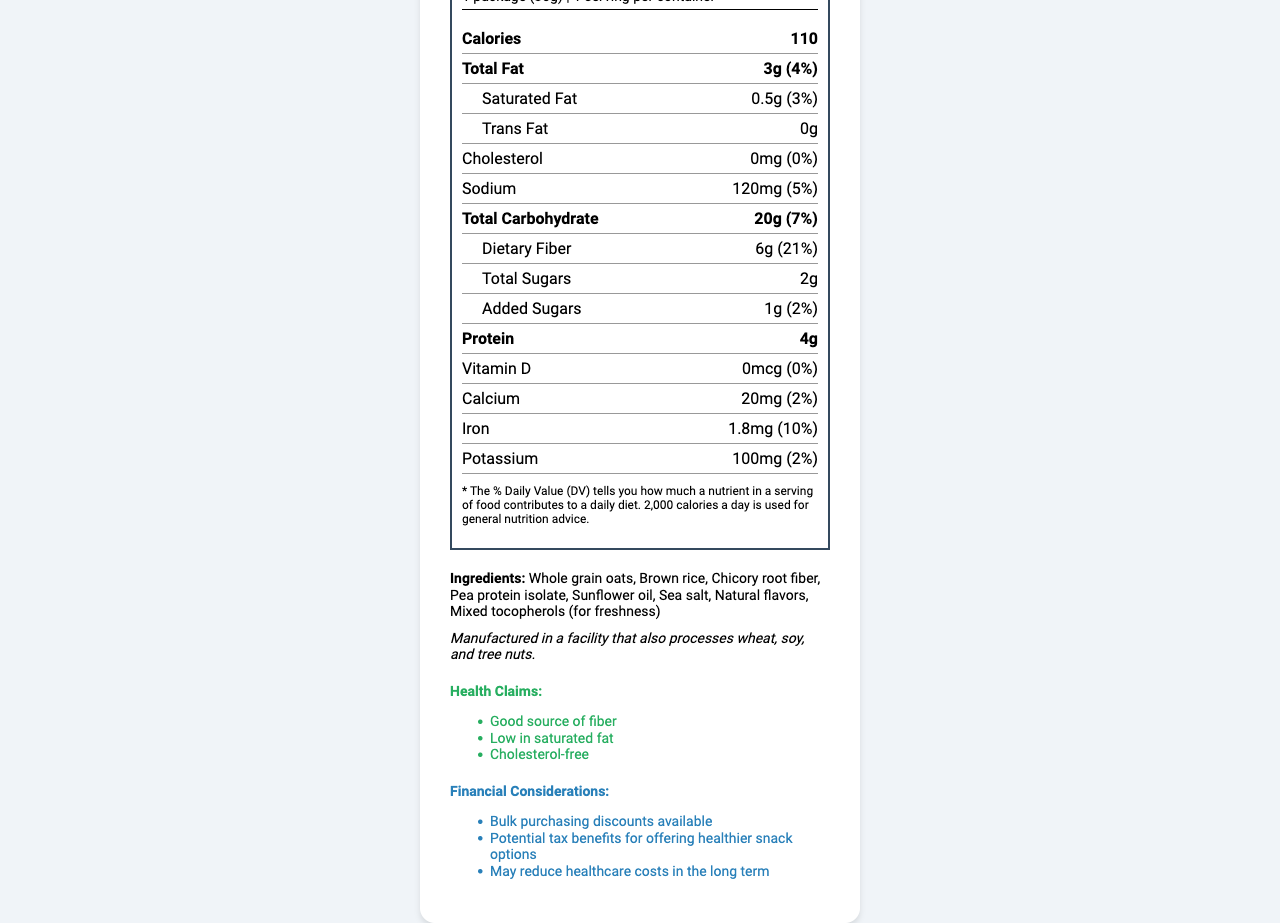what is the serving size? The serving size is specified directly under the product name in the "Nutrition Facts" label.
Answer: 1 package (30g) how many calories are there per serving? The calorie count per serving is listed near the top of the "Nutrition Facts" label, under the serving size information.
Answer: 110 how much dietary fiber is in a serving of FiberCrunch Lite? The amount of dietary fiber is listed in the "Total Carbohydrate" section of the "Nutrition Facts" label.
Answer: 6g what is the daily value percentage for iron? The daily value percentage for iron is shown in the nutrient section under the entry for iron.
Answer: 10% are there any trans fats in FiberCrunch Lite? The document specifies "Trans Fat: 0g", indicating no trans fats in the product.
Answer: No Which of the following is not an ingredient in FiberCrunch Lite? 
A. Whole grain oats 
B. Chicory root fiber 
C. High fructose corn syrup 
D. Pea protein isolate The list of ingredients does not include high fructose corn syrup, only whole grain oats, chicory root fiber, and pea protein isolate.
Answer: C. High fructose corn syrup how is FiberCrunch Lite aligned with corporate wellness initiatives? 
A. Promotes employee health and well-being 
B. Generates high revenue 
C. Has longer shelf life 
D. Is low in cost per unit The document lists promoting employee health and well-being as one of the potential benefits.
Answer: A. Promotes employee health and well-being is FiberCrunch Lite Non-GMO Project Verified? The product is specified as "Non-GMO Project Verified" in the document.
Answer: Yes Summarize the main idea of this document. The document provides detailed nutritional information, ingredients, allergen info, health claims, financial considerations, and potential benefits of FiberCrunch Lite.
Answer: FiberCrunch Lite is a low-fat, high-fiber snack with various health benefits and financial considerations, suitable for the office vending machine. Does FiberCrunch Lite contain any wheat allergens? The document states that it is manufactured in a facility that processes wheat, soy, and tree nuts; however, it does not explicitly state whether the product itself contains wheat.
Answer: Cannot be determined what is the cost per unit for FiberCrunch Lite? The cost per unit is listed under the financial considerations section in the document.
Answer: $1.25 how much saturated fat is in a package? The amount of saturated fat is specified in the "Total Fat" section of the "Nutrition Facts" label.
Answer: 0.5g what are the potential financial benefits of offering FiberCrunch Lite in the office? The financial benefits are listed in the financial considerations section of the document.
Answer: Bulk purchasing discounts, potential tax benefits, reduced healthcare costs how long is the shelf life of FiberCrunch Lite? The shelf life is specified under the product details in the document.
Answer: 6 months 